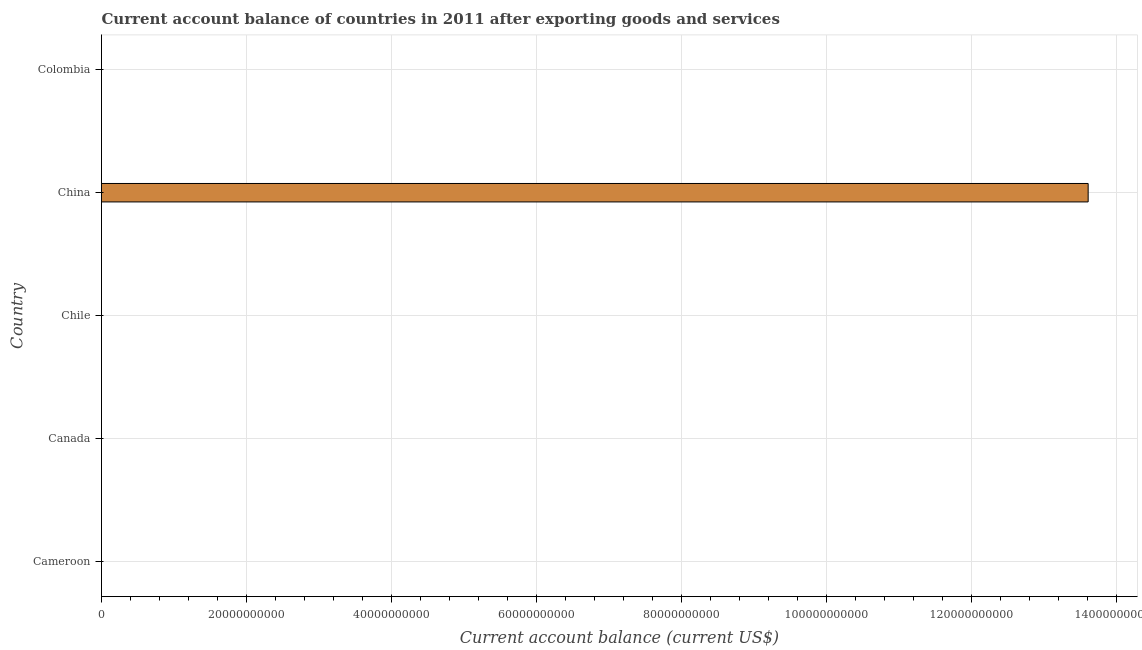Does the graph contain grids?
Make the answer very short. Yes. What is the title of the graph?
Make the answer very short. Current account balance of countries in 2011 after exporting goods and services. What is the label or title of the X-axis?
Provide a succinct answer. Current account balance (current US$). What is the label or title of the Y-axis?
Offer a very short reply. Country. What is the current account balance in Chile?
Your response must be concise. 0. Across all countries, what is the maximum current account balance?
Make the answer very short. 1.36e+11. What is the sum of the current account balance?
Offer a very short reply. 1.36e+11. What is the average current account balance per country?
Offer a terse response. 2.72e+1. What is the difference between the highest and the lowest current account balance?
Keep it short and to the point. 1.36e+11. Are all the bars in the graph horizontal?
Make the answer very short. Yes. How many countries are there in the graph?
Keep it short and to the point. 5. What is the difference between two consecutive major ticks on the X-axis?
Provide a short and direct response. 2.00e+1. What is the Current account balance (current US$) in Cameroon?
Offer a very short reply. 0. What is the Current account balance (current US$) of Canada?
Your response must be concise. 0. What is the Current account balance (current US$) in China?
Provide a short and direct response. 1.36e+11. 